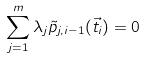Convert formula to latex. <formula><loc_0><loc_0><loc_500><loc_500>\sum _ { j = 1 } ^ { m } \lambda _ { j } \tilde { p } _ { j , i - 1 } ( \vec { t } _ { i } ) = 0</formula> 